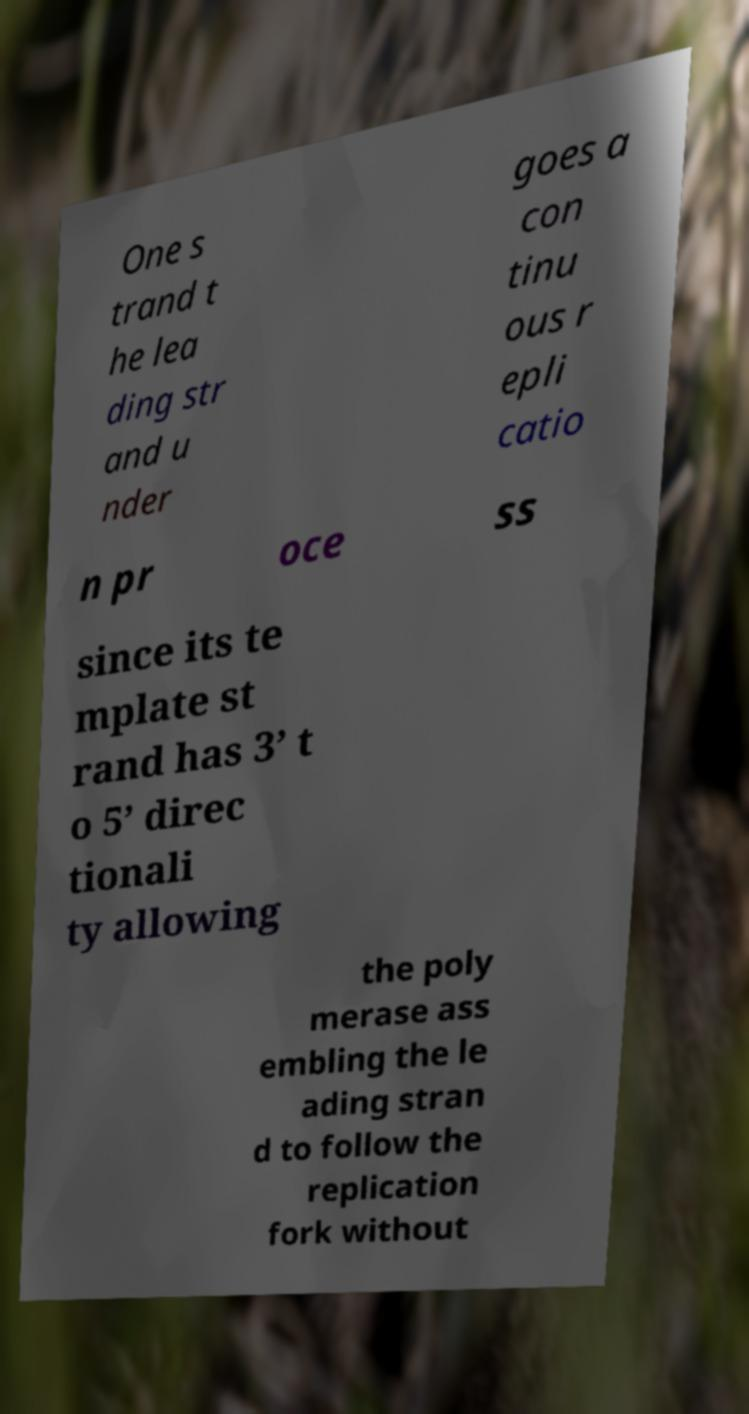There's text embedded in this image that I need extracted. Can you transcribe it verbatim? One s trand t he lea ding str and u nder goes a con tinu ous r epli catio n pr oce ss since its te mplate st rand has 3’ t o 5’ direc tionali ty allowing the poly merase ass embling the le ading stran d to follow the replication fork without 